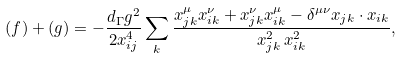<formula> <loc_0><loc_0><loc_500><loc_500>( f ) + ( g ) = - \frac { d _ { \Gamma } g ^ { 2 } } { 2 x _ { i j } ^ { 4 } } \sum _ { k } \frac { x _ { j k } ^ { \mu } x _ { i k } ^ { \nu } + x _ { j k } ^ { \nu } x _ { i k } ^ { \mu } - \delta ^ { \mu \nu } x _ { j k } \cdot x _ { i k } } { x _ { j k } ^ { 2 } \, x _ { i k } ^ { 2 } } ,</formula> 